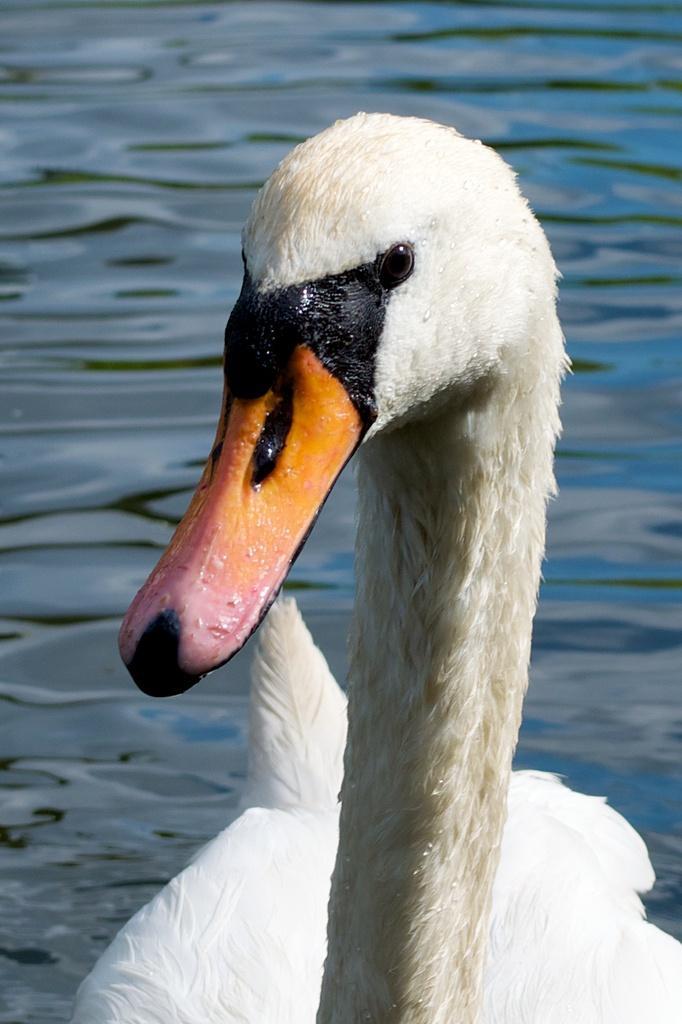Describe this image in one or two sentences. In this image we can see a duck, also we can see the water. 